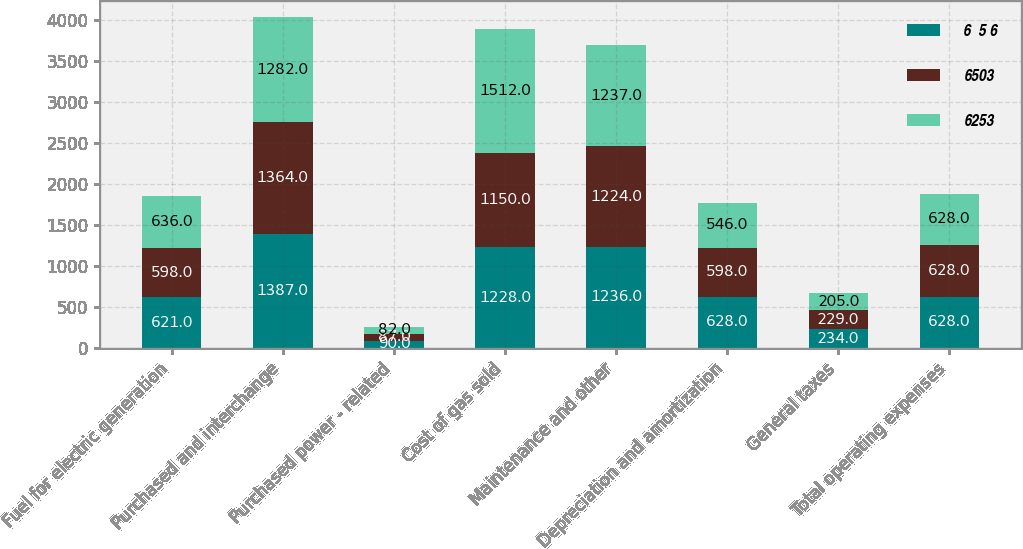Convert chart. <chart><loc_0><loc_0><loc_500><loc_500><stacked_bar_chart><ecel><fcel>Fuel for electric generation<fcel>Purchased and interchange<fcel>Purchased power - related<fcel>Cost of gas sold<fcel>Maintenance and other<fcel>Depreciation and amortization<fcel>General taxes<fcel>Total operating expenses<nl><fcel>6  5 6<fcel>621<fcel>1387<fcel>90<fcel>1228<fcel>1236<fcel>628<fcel>234<fcel>628<nl><fcel>6503<fcel>598<fcel>1364<fcel>87<fcel>1150<fcel>1224<fcel>598<fcel>229<fcel>628<nl><fcel>6253<fcel>636<fcel>1282<fcel>82<fcel>1512<fcel>1237<fcel>546<fcel>205<fcel>628<nl></chart> 